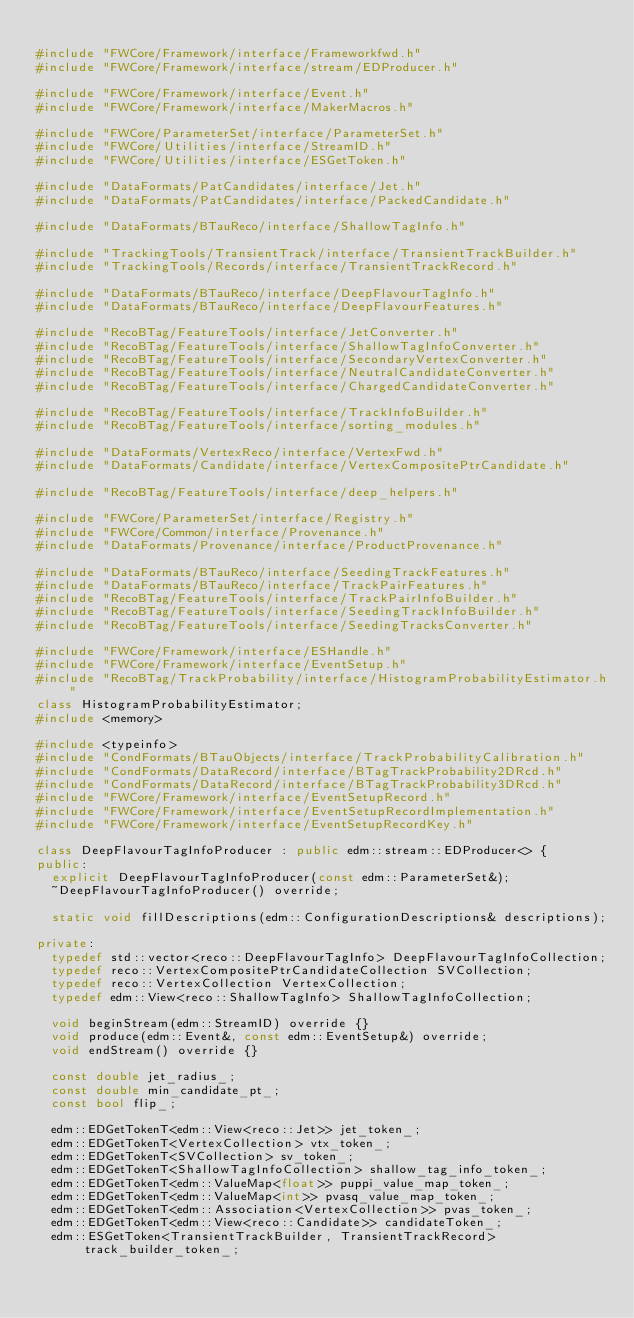<code> <loc_0><loc_0><loc_500><loc_500><_C++_>
#include "FWCore/Framework/interface/Frameworkfwd.h"
#include "FWCore/Framework/interface/stream/EDProducer.h"

#include "FWCore/Framework/interface/Event.h"
#include "FWCore/Framework/interface/MakerMacros.h"

#include "FWCore/ParameterSet/interface/ParameterSet.h"
#include "FWCore/Utilities/interface/StreamID.h"
#include "FWCore/Utilities/interface/ESGetToken.h"

#include "DataFormats/PatCandidates/interface/Jet.h"
#include "DataFormats/PatCandidates/interface/PackedCandidate.h"

#include "DataFormats/BTauReco/interface/ShallowTagInfo.h"

#include "TrackingTools/TransientTrack/interface/TransientTrackBuilder.h"
#include "TrackingTools/Records/interface/TransientTrackRecord.h"

#include "DataFormats/BTauReco/interface/DeepFlavourTagInfo.h"
#include "DataFormats/BTauReco/interface/DeepFlavourFeatures.h"

#include "RecoBTag/FeatureTools/interface/JetConverter.h"
#include "RecoBTag/FeatureTools/interface/ShallowTagInfoConverter.h"
#include "RecoBTag/FeatureTools/interface/SecondaryVertexConverter.h"
#include "RecoBTag/FeatureTools/interface/NeutralCandidateConverter.h"
#include "RecoBTag/FeatureTools/interface/ChargedCandidateConverter.h"

#include "RecoBTag/FeatureTools/interface/TrackInfoBuilder.h"
#include "RecoBTag/FeatureTools/interface/sorting_modules.h"

#include "DataFormats/VertexReco/interface/VertexFwd.h"
#include "DataFormats/Candidate/interface/VertexCompositePtrCandidate.h"

#include "RecoBTag/FeatureTools/interface/deep_helpers.h"

#include "FWCore/ParameterSet/interface/Registry.h"
#include "FWCore/Common/interface/Provenance.h"
#include "DataFormats/Provenance/interface/ProductProvenance.h"

#include "DataFormats/BTauReco/interface/SeedingTrackFeatures.h"
#include "DataFormats/BTauReco/interface/TrackPairFeatures.h"
#include "RecoBTag/FeatureTools/interface/TrackPairInfoBuilder.h"
#include "RecoBTag/FeatureTools/interface/SeedingTrackInfoBuilder.h"
#include "RecoBTag/FeatureTools/interface/SeedingTracksConverter.h"

#include "FWCore/Framework/interface/ESHandle.h"
#include "FWCore/Framework/interface/EventSetup.h"
#include "RecoBTag/TrackProbability/interface/HistogramProbabilityEstimator.h"
class HistogramProbabilityEstimator;
#include <memory>

#include <typeinfo>
#include "CondFormats/BTauObjects/interface/TrackProbabilityCalibration.h"
#include "CondFormats/DataRecord/interface/BTagTrackProbability2DRcd.h"
#include "CondFormats/DataRecord/interface/BTagTrackProbability3DRcd.h"
#include "FWCore/Framework/interface/EventSetupRecord.h"
#include "FWCore/Framework/interface/EventSetupRecordImplementation.h"
#include "FWCore/Framework/interface/EventSetupRecordKey.h"

class DeepFlavourTagInfoProducer : public edm::stream::EDProducer<> {
public:
  explicit DeepFlavourTagInfoProducer(const edm::ParameterSet&);
  ~DeepFlavourTagInfoProducer() override;

  static void fillDescriptions(edm::ConfigurationDescriptions& descriptions);

private:
  typedef std::vector<reco::DeepFlavourTagInfo> DeepFlavourTagInfoCollection;
  typedef reco::VertexCompositePtrCandidateCollection SVCollection;
  typedef reco::VertexCollection VertexCollection;
  typedef edm::View<reco::ShallowTagInfo> ShallowTagInfoCollection;

  void beginStream(edm::StreamID) override {}
  void produce(edm::Event&, const edm::EventSetup&) override;
  void endStream() override {}

  const double jet_radius_;
  const double min_candidate_pt_;
  const bool flip_;

  edm::EDGetTokenT<edm::View<reco::Jet>> jet_token_;
  edm::EDGetTokenT<VertexCollection> vtx_token_;
  edm::EDGetTokenT<SVCollection> sv_token_;
  edm::EDGetTokenT<ShallowTagInfoCollection> shallow_tag_info_token_;
  edm::EDGetTokenT<edm::ValueMap<float>> puppi_value_map_token_;
  edm::EDGetTokenT<edm::ValueMap<int>> pvasq_value_map_token_;
  edm::EDGetTokenT<edm::Association<VertexCollection>> pvas_token_;
  edm::EDGetTokenT<edm::View<reco::Candidate>> candidateToken_;
  edm::ESGetToken<TransientTrackBuilder, TransientTrackRecord> track_builder_token_;</code> 